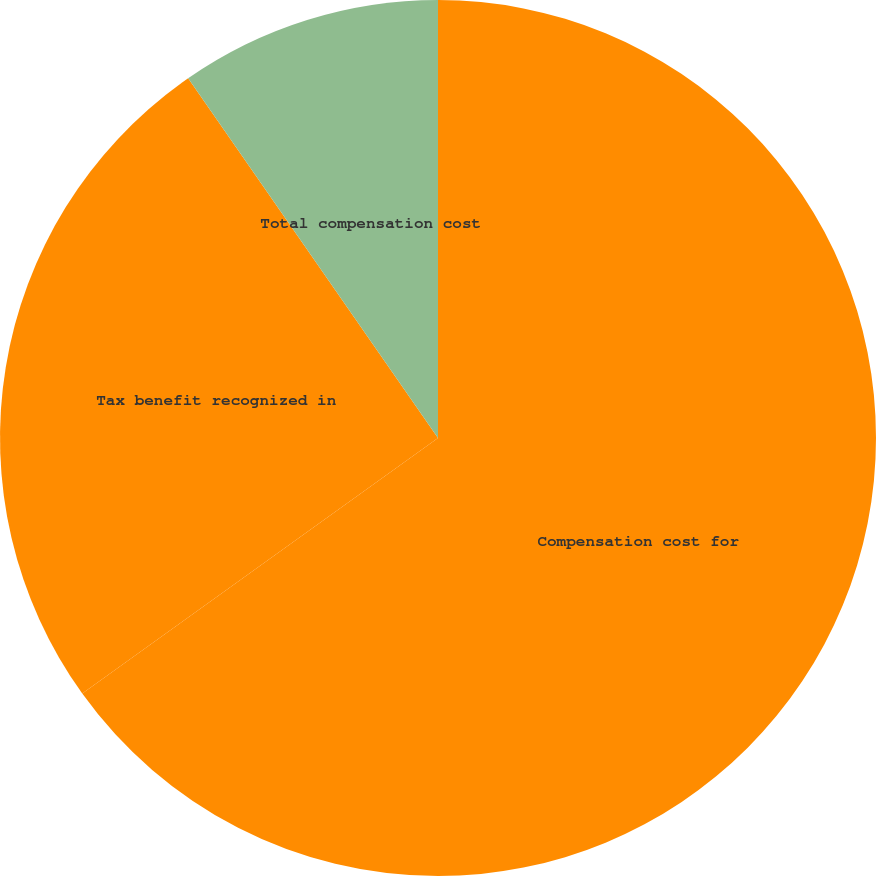<chart> <loc_0><loc_0><loc_500><loc_500><pie_chart><fcel>Compensation cost for<fcel>Tax benefit recognized in<fcel>Total compensation cost<nl><fcel>65.08%<fcel>25.25%<fcel>9.66%<nl></chart> 